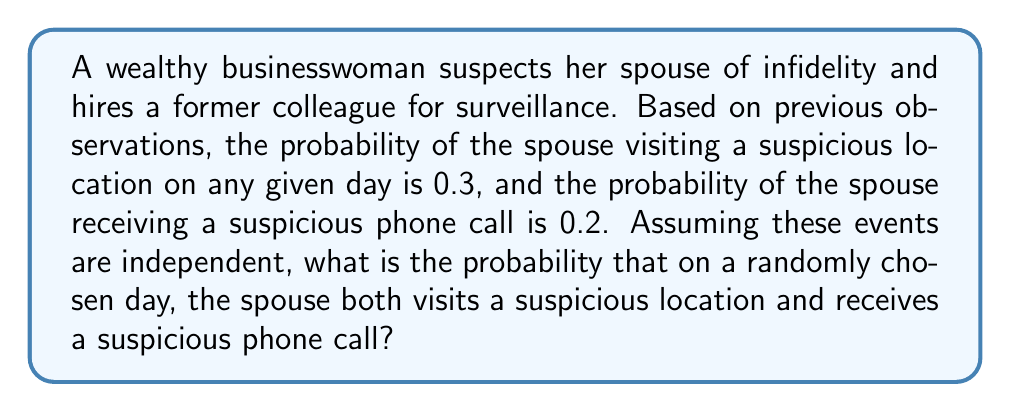Give your solution to this math problem. To solve this problem, we need to use the multiplication rule for independent events. When two events A and B are independent, the probability of both events occurring simultaneously is the product of their individual probabilities.

Let's define our events:
A = Spouse visits a suspicious location
B = Spouse receives a suspicious phone call

Given:
P(A) = 0.3
P(B) = 0.2

We want to find P(A and B), which is equivalent to P(A ∩ B) for independent events.

The formula for independent events is:

$$ P(A \cap B) = P(A) \times P(B) $$

Substituting the given probabilities:

$$ P(A \cap B) = 0.3 \times 0.2 $$

Calculating:

$$ P(A \cap B) = 0.06 $$

Therefore, the probability that on a randomly chosen day, the spouse both visits a suspicious location and receives a suspicious phone call is 0.06 or 6%.
Answer: 0.06 or 6% 